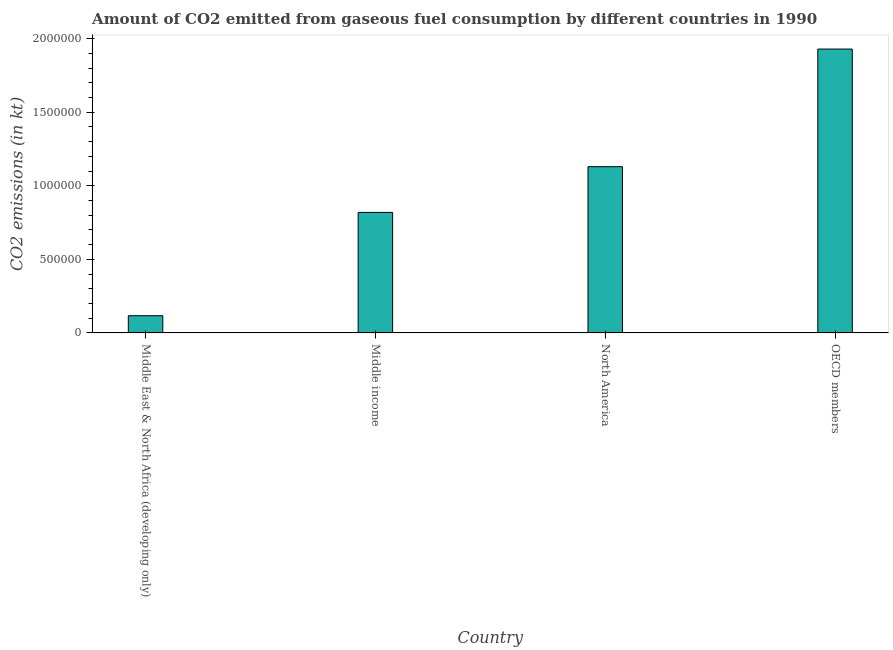Does the graph contain grids?
Your answer should be very brief. No. What is the title of the graph?
Keep it short and to the point. Amount of CO2 emitted from gaseous fuel consumption by different countries in 1990. What is the label or title of the Y-axis?
Give a very brief answer. CO2 emissions (in kt). What is the co2 emissions from gaseous fuel consumption in Middle East & North Africa (developing only)?
Provide a short and direct response. 1.17e+05. Across all countries, what is the maximum co2 emissions from gaseous fuel consumption?
Your answer should be compact. 1.93e+06. Across all countries, what is the minimum co2 emissions from gaseous fuel consumption?
Your answer should be compact. 1.17e+05. In which country was the co2 emissions from gaseous fuel consumption maximum?
Provide a succinct answer. OECD members. In which country was the co2 emissions from gaseous fuel consumption minimum?
Ensure brevity in your answer.  Middle East & North Africa (developing only). What is the sum of the co2 emissions from gaseous fuel consumption?
Provide a short and direct response. 4.00e+06. What is the difference between the co2 emissions from gaseous fuel consumption in Middle East & North Africa (developing only) and OECD members?
Your answer should be very brief. -1.81e+06. What is the average co2 emissions from gaseous fuel consumption per country?
Offer a terse response. 9.99e+05. What is the median co2 emissions from gaseous fuel consumption?
Keep it short and to the point. 9.75e+05. In how many countries, is the co2 emissions from gaseous fuel consumption greater than 900000 kt?
Your answer should be very brief. 2. What is the ratio of the co2 emissions from gaseous fuel consumption in Middle income to that in North America?
Provide a succinct answer. 0.72. What is the difference between the highest and the second highest co2 emissions from gaseous fuel consumption?
Your response must be concise. 8.00e+05. Is the sum of the co2 emissions from gaseous fuel consumption in Middle East & North Africa (developing only) and North America greater than the maximum co2 emissions from gaseous fuel consumption across all countries?
Offer a very short reply. No. What is the difference between the highest and the lowest co2 emissions from gaseous fuel consumption?
Give a very brief answer. 1.81e+06. In how many countries, is the co2 emissions from gaseous fuel consumption greater than the average co2 emissions from gaseous fuel consumption taken over all countries?
Your response must be concise. 2. How many countries are there in the graph?
Make the answer very short. 4. Are the values on the major ticks of Y-axis written in scientific E-notation?
Your response must be concise. No. What is the CO2 emissions (in kt) in Middle East & North Africa (developing only)?
Your answer should be very brief. 1.17e+05. What is the CO2 emissions (in kt) of Middle income?
Your answer should be compact. 8.19e+05. What is the CO2 emissions (in kt) of North America?
Your answer should be very brief. 1.13e+06. What is the CO2 emissions (in kt) in OECD members?
Give a very brief answer. 1.93e+06. What is the difference between the CO2 emissions (in kt) in Middle East & North Africa (developing only) and Middle income?
Give a very brief answer. -7.02e+05. What is the difference between the CO2 emissions (in kt) in Middle East & North Africa (developing only) and North America?
Give a very brief answer. -1.01e+06. What is the difference between the CO2 emissions (in kt) in Middle East & North Africa (developing only) and OECD members?
Your answer should be compact. -1.81e+06. What is the difference between the CO2 emissions (in kt) in Middle income and North America?
Provide a short and direct response. -3.11e+05. What is the difference between the CO2 emissions (in kt) in Middle income and OECD members?
Offer a terse response. -1.11e+06. What is the difference between the CO2 emissions (in kt) in North America and OECD members?
Offer a very short reply. -8.00e+05. What is the ratio of the CO2 emissions (in kt) in Middle East & North Africa (developing only) to that in Middle income?
Ensure brevity in your answer.  0.14. What is the ratio of the CO2 emissions (in kt) in Middle East & North Africa (developing only) to that in North America?
Make the answer very short. 0.1. What is the ratio of the CO2 emissions (in kt) in Middle East & North Africa (developing only) to that in OECD members?
Ensure brevity in your answer.  0.06. What is the ratio of the CO2 emissions (in kt) in Middle income to that in North America?
Provide a succinct answer. 0.72. What is the ratio of the CO2 emissions (in kt) in Middle income to that in OECD members?
Give a very brief answer. 0.42. What is the ratio of the CO2 emissions (in kt) in North America to that in OECD members?
Provide a short and direct response. 0.59. 